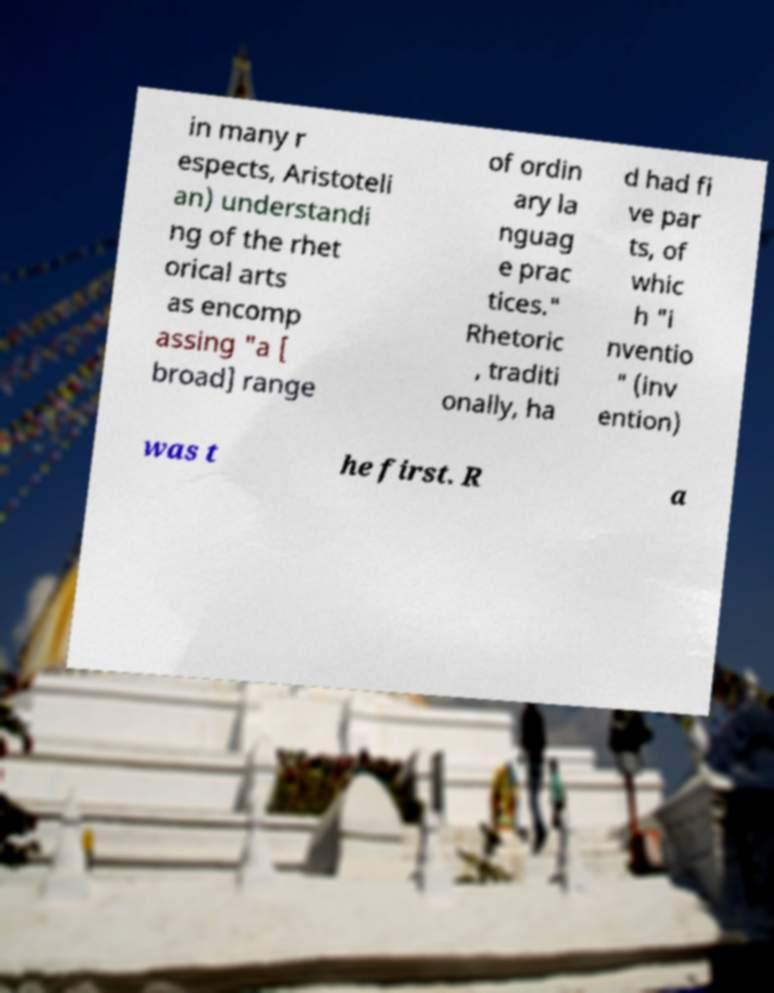Please read and relay the text visible in this image. What does it say? in many r espects, Aristoteli an) understandi ng of the rhet orical arts as encomp assing "a [ broad] range of ordin ary la nguag e prac tices." Rhetoric , traditi onally, ha d had fi ve par ts, of whic h "i nventio " (inv ention) was t he first. R a 